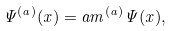Convert formula to latex. <formula><loc_0><loc_0><loc_500><loc_500>\Psi ^ { ( a ) } ( x ) = \L a m ^ { ( a ) } \Psi ( x ) ,</formula> 